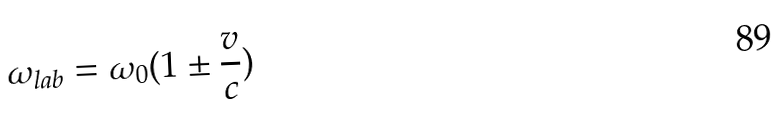<formula> <loc_0><loc_0><loc_500><loc_500>\omega _ { l a b } = \omega _ { 0 } ( 1 \pm \frac { v } { c } )</formula> 